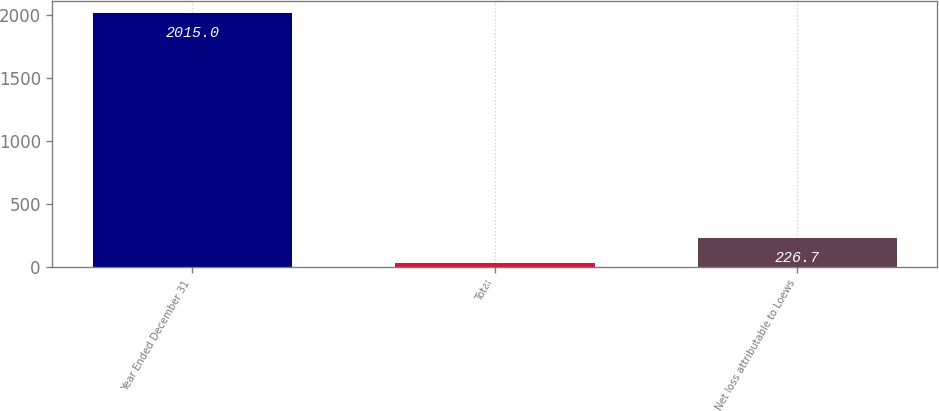Convert chart to OTSL. <chart><loc_0><loc_0><loc_500><loc_500><bar_chart><fcel>Year Ended December 31<fcel>Total<fcel>Net loss attributable to Loews<nl><fcel>2015<fcel>28<fcel>226.7<nl></chart> 